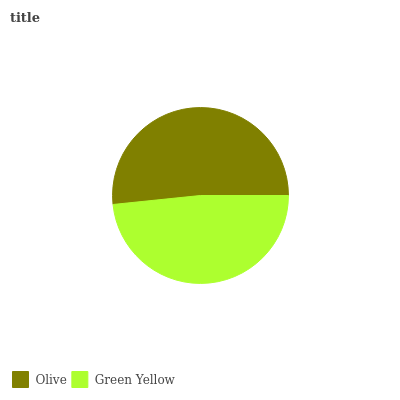Is Green Yellow the minimum?
Answer yes or no. Yes. Is Olive the maximum?
Answer yes or no. Yes. Is Green Yellow the maximum?
Answer yes or no. No. Is Olive greater than Green Yellow?
Answer yes or no. Yes. Is Green Yellow less than Olive?
Answer yes or no. Yes. Is Green Yellow greater than Olive?
Answer yes or no. No. Is Olive less than Green Yellow?
Answer yes or no. No. Is Olive the high median?
Answer yes or no. Yes. Is Green Yellow the low median?
Answer yes or no. Yes. Is Green Yellow the high median?
Answer yes or no. No. Is Olive the low median?
Answer yes or no. No. 